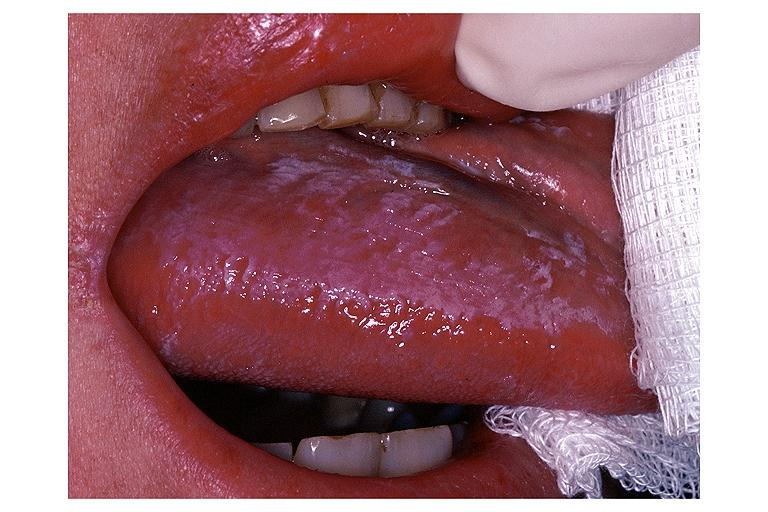what does this image show?
Answer the question using a single word or phrase. Oral hairy leukoplakia 